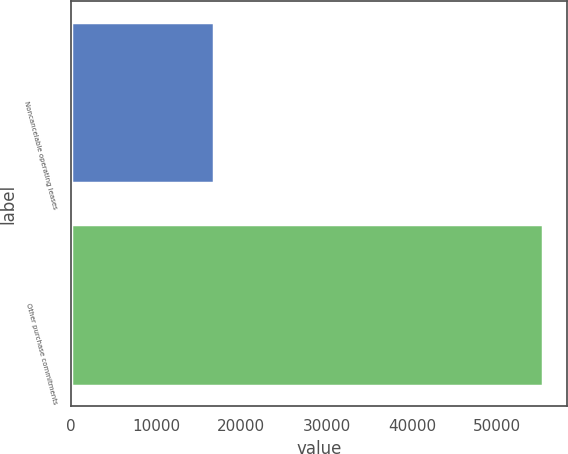<chart> <loc_0><loc_0><loc_500><loc_500><bar_chart><fcel>Noncancelable operating leases<fcel>Other purchase commitments<nl><fcel>16757<fcel>55394<nl></chart> 